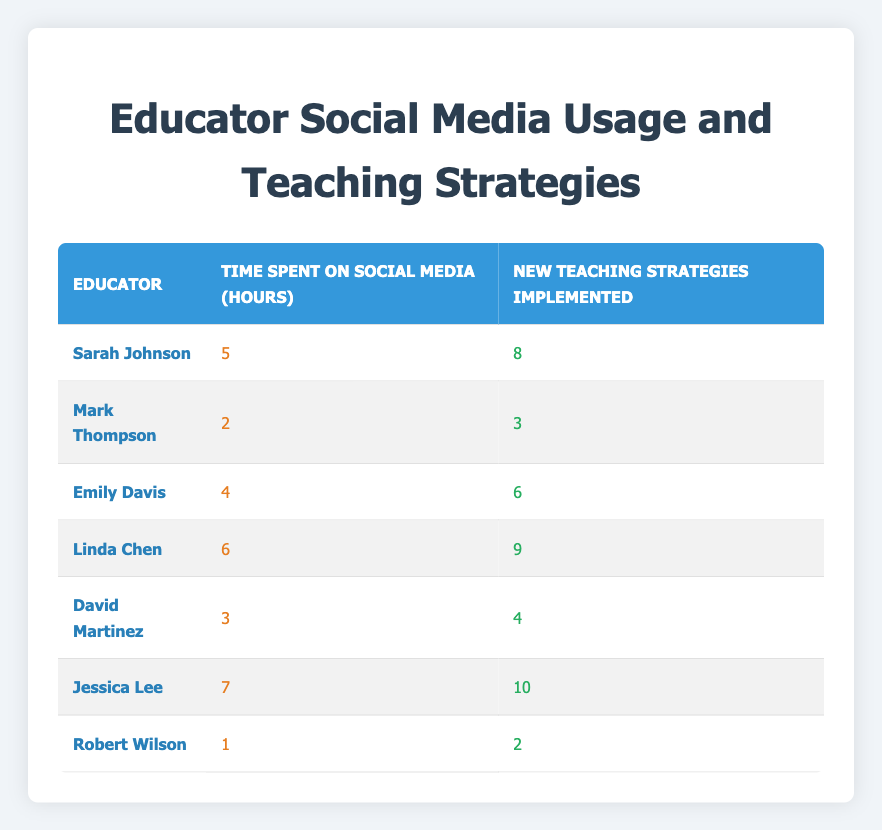What is the time spent on social media by Linda Chen? From the table, we see Linda Chen's row, which states that the time spent on social media is 6 hours.
Answer: 6 Who implemented the most new teaching strategies? By examining the "New Teaching Strategies Implemented" column, we find that Jessica Lee has implemented the highest number, which is 10.
Answer: Jessica Lee Is it true that Robert Wilson spent more time on social media than David Martinez? Looking at the "Time Spent on Social Media" column, Robert Wilson has 1 hour while David Martinez has 3 hours. Therefore, the statement is false.
Answer: No What is the average number of new teaching strategies implemented by the educators? To find the average, sum the new strategies (8 + 3 + 6 + 9 + 4 + 10 + 2 = 42) and divide by the number of educators (7). Thus, the average is 42 / 7 = 6.
Answer: 6 How many educators spent more than 4 hours on social media? We check the "Time Spent on Social Media" column and find that Sarah Johnson, Linda Chen, and Jessica Lee all spent more than 4 hours (5, 6, and 7 hours respectively), making a total of 3 educators.
Answer: 3 What is the difference in the number of strategies implemented between the educator with the highest and lowest social media usage? Jessica Lee (7 hours, 10 strategies) and Robert Wilson (1 hour, 2 strategies) are the respective educators. The difference in strategies is 10 - 2 = 8.
Answer: 8 Which educator has the highest ratio of new teaching strategies implemented to time spent on social media? To find the ratio, we calculate each educator's strategies divided by their time spent. Jessica Lee has the highest at 10 strategies / 7 hours = 1.43. Checking others shows this is the highest ratio.
Answer: Jessica Lee 